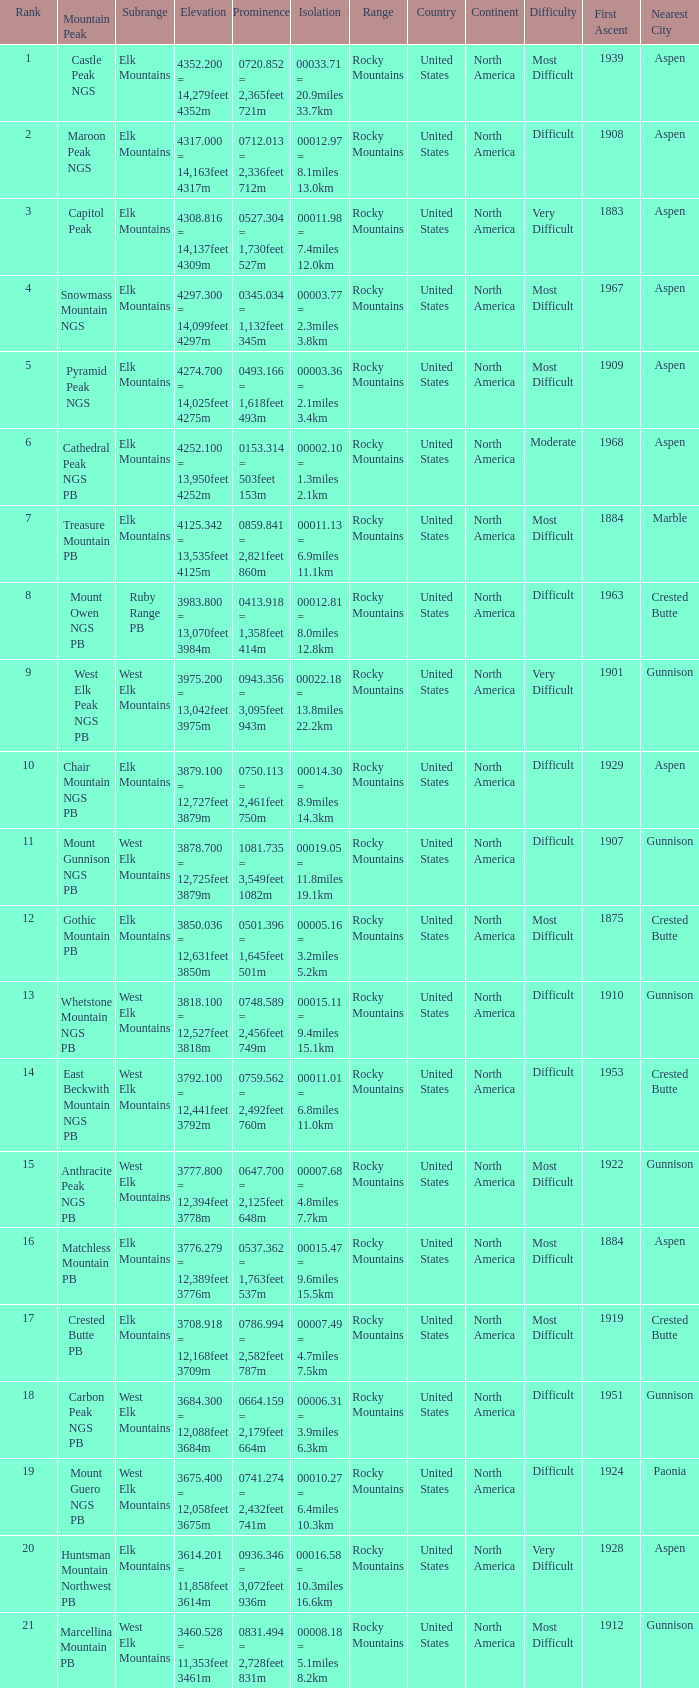Name the Rank of Rank Mountain Peak of crested butte pb? 17.0. 